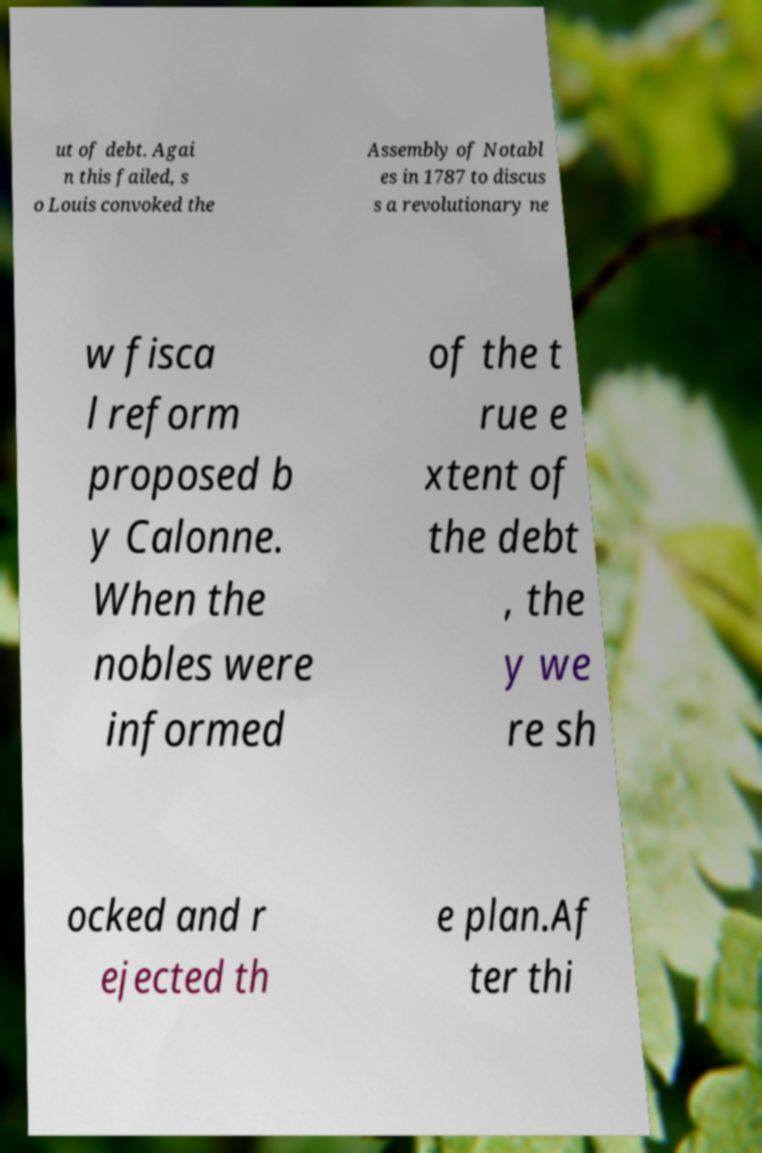Could you extract and type out the text from this image? ut of debt. Agai n this failed, s o Louis convoked the Assembly of Notabl es in 1787 to discus s a revolutionary ne w fisca l reform proposed b y Calonne. When the nobles were informed of the t rue e xtent of the debt , the y we re sh ocked and r ejected th e plan.Af ter thi 